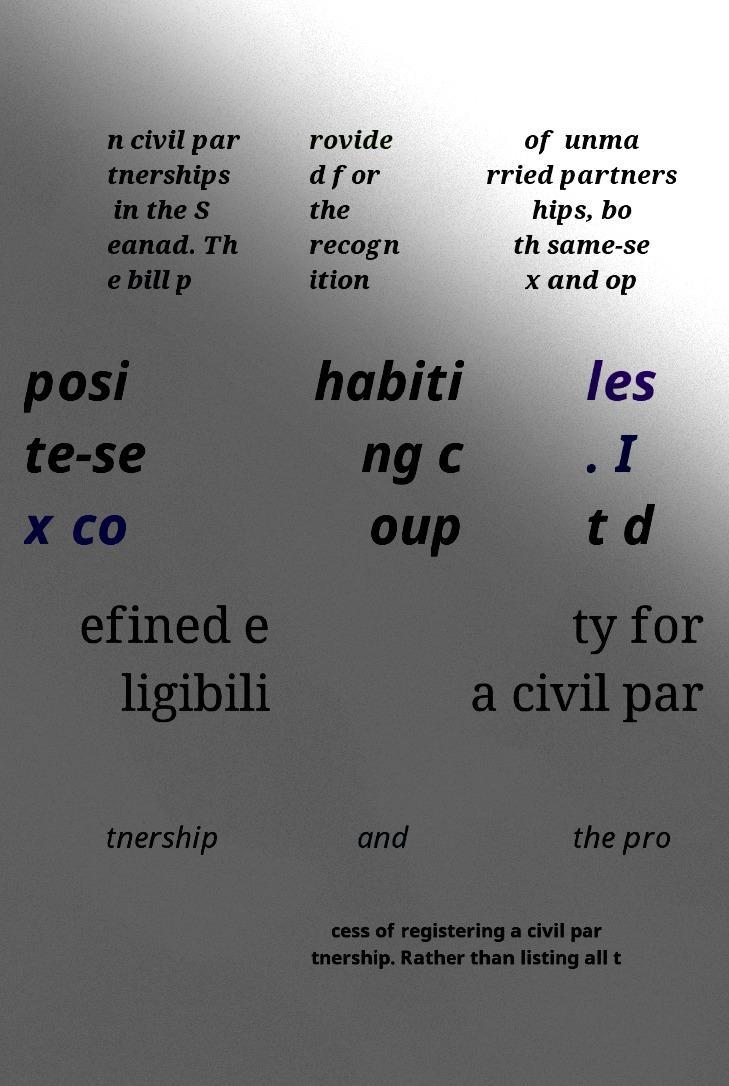Please identify and transcribe the text found in this image. n civil par tnerships in the S eanad. Th e bill p rovide d for the recogn ition of unma rried partners hips, bo th same-se x and op posi te-se x co habiti ng c oup les . I t d efined e ligibili ty for a civil par tnership and the pro cess of registering a civil par tnership. Rather than listing all t 